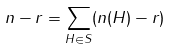<formula> <loc_0><loc_0><loc_500><loc_500>n - r = \sum _ { H \in S } ( n ( H ) - r )</formula> 